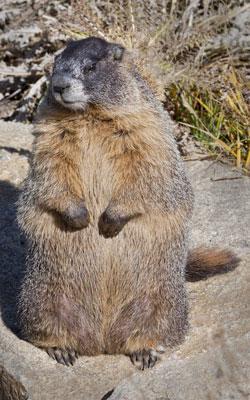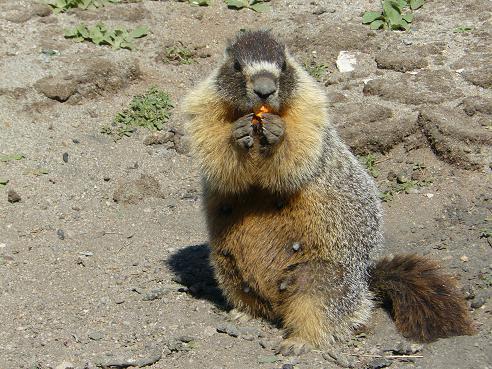The first image is the image on the left, the second image is the image on the right. Evaluate the accuracy of this statement regarding the images: "The animal in the image on the right is looking toward the camera". Is it true? Answer yes or no. Yes. 